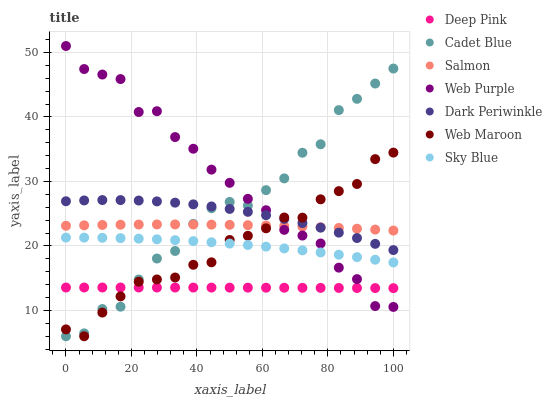Does Deep Pink have the minimum area under the curve?
Answer yes or no. Yes. Does Web Purple have the maximum area under the curve?
Answer yes or no. Yes. Does Salmon have the minimum area under the curve?
Answer yes or no. No. Does Salmon have the maximum area under the curve?
Answer yes or no. No. Is Deep Pink the smoothest?
Answer yes or no. Yes. Is Cadet Blue the roughest?
Answer yes or no. Yes. Is Salmon the smoothest?
Answer yes or no. No. Is Salmon the roughest?
Answer yes or no. No. Does Cadet Blue have the lowest value?
Answer yes or no. Yes. Does Salmon have the lowest value?
Answer yes or no. No. Does Web Purple have the highest value?
Answer yes or no. Yes. Does Salmon have the highest value?
Answer yes or no. No. Is Deep Pink less than Sky Blue?
Answer yes or no. Yes. Is Dark Periwinkle greater than Sky Blue?
Answer yes or no. Yes. Does Web Purple intersect Deep Pink?
Answer yes or no. Yes. Is Web Purple less than Deep Pink?
Answer yes or no. No. Is Web Purple greater than Deep Pink?
Answer yes or no. No. Does Deep Pink intersect Sky Blue?
Answer yes or no. No. 